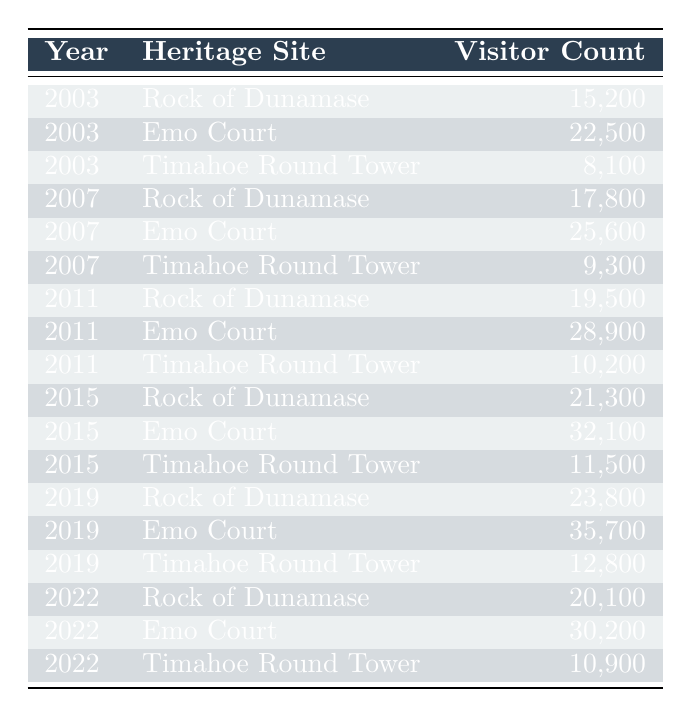What was the visitor count at Emo Court in 2019? According to the table, the visitor count at Emo Court in 2019 is explicitly listed. Looking at the row for that year and heritage site, it states the number is 35,700.
Answer: 35,700 What was the total visitor count for Rock of Dunamase over the years in the table? To find the total visitor count for Rock of Dunamase, we add the values from each year: 15,200 (2003) + 17,800 (2007) + 19,500 (2011) + 21,300 (2015) + 23,800 (2019) + 20,100 (2022) = 117,700.
Answer: 117,700 Did visitor counts at Timahoe Round Tower ever exceed 12,000? By checking the values in the table for Timahoe Round Tower, the counts in 2003, 2007, 2011, 2015, and 2019 show that the highest count is 12,800 (2019), which exceeds 12,000.
Answer: Yes Which heritage site had the highest visitor count in 2022? To determine which heritage site had the highest count in 2022, we compare the visitor counts: Rock of Dunamase (20,100), Emo Court (30,200), and Timahoe Round Tower (10,900). Emo Court has the highest count of 30,200.
Answer: Emo Court What is the average visitor count for Timahoe Round Tower across the years in the table? The visitor counts for Timahoe Round Tower are: 8,100 (2003), 9,300 (2007), 10,200 (2011), 11,500 (2015), 12,800 (2019), and 10,900 (2022). Summing these gives 8,100 + 9,300 + 10,200 + 11,500 + 12,800 + 10,900 = 62,800. There are 6 data points, so the average is 62,800 / 6 = 10,467.
Answer: 10,467 Was there a decline in visitor numbers to Emo Court from 2019 to 2022? To analyze the decline, we need to compare the visitor counts: in 2019, Emo Court had 35,700 visitors, and in 2022, it had 30,200. This shows a drop of 5,500 visitors.
Answer: Yes How many years are represented in the data for Rock of Dunamase? The years for Rock of Dunamase in the table are 2003, 2007, 2011, 2015, 2019, and 2022, which makes a total of 6 distinct years.
Answer: 6 years What is the difference in visitor counts for Emo Court between 2011 and 2015? To find the difference, we subtract the visitor count in 2011 (28,900) from the visitor count in 2015 (32,100): 32,100 - 28,900 = 3,200.
Answer: 3,200 In which year did Timahoe Round Tower have the lowest visitor count? Checking the table, we observe that the visitor count for Timahoe Round Tower in 2003 is 8,100, and it is the lowest in comparison to other years listed.
Answer: 2003 What year saw the highest number of visitors overall across the three sites? Totaling the visitor counts for all sites in each year, we find: 2003 (15,200 + 22,500 + 8,100 = 45,800), 2007 (17,800 + 25,600 + 9,300 = 52,700), 2011 (19,500 + 28,900 + 10,200 = 58,600), 2015 (21,300 + 32,100 + 11,500 = 64,900), 2019 (23,800 + 35,700 + 12,800 = 72,300), and 2022 (20,100 + 30,200 + 10,900 = 61,200). Therefore, 2019 has the highest visitor count of 72,300.
Answer: 2019 Was the visitor count at Emo Court consistently increasing from 2003 to 2019? Checking the visitor counts for Emo Court: 22,500 (2003), 25,600 (2007), 28,900 (2011), 32,100 (2015), and 35,700 (2019), we see that the numbers have increased each year, indicating a consistent rise.
Answer: Yes 